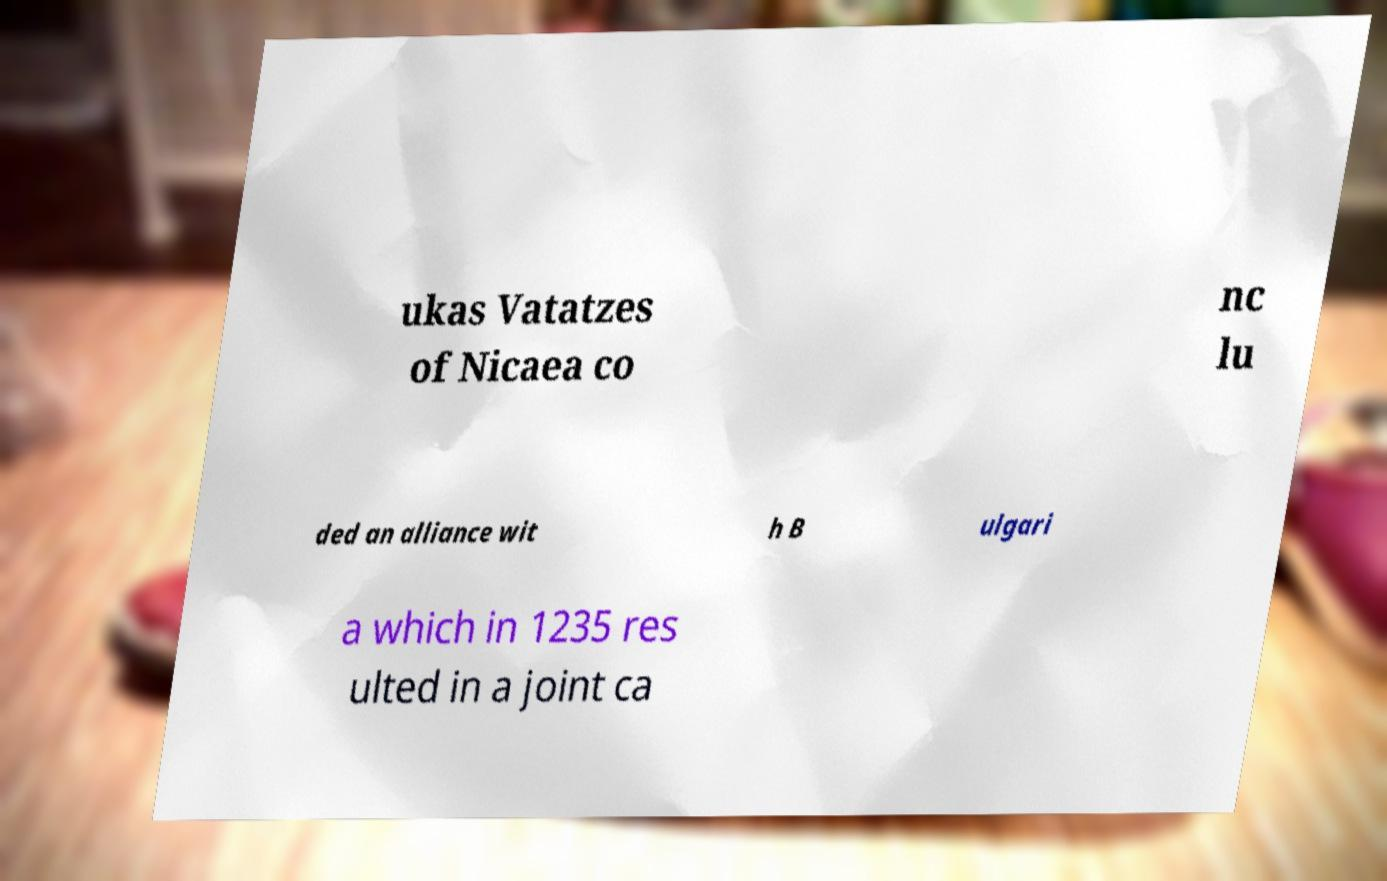I need the written content from this picture converted into text. Can you do that? ukas Vatatzes of Nicaea co nc lu ded an alliance wit h B ulgari a which in 1235 res ulted in a joint ca 